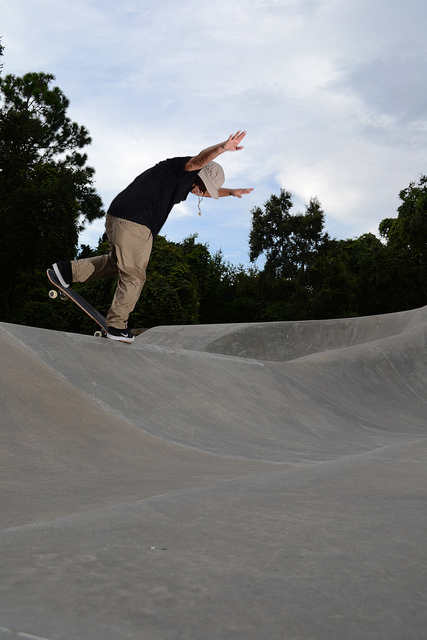<image>Which leg is in the air? I don't know if the leg is in the air. It can be left. Which leg is in the air? It can be seen that the left leg is in the air. 